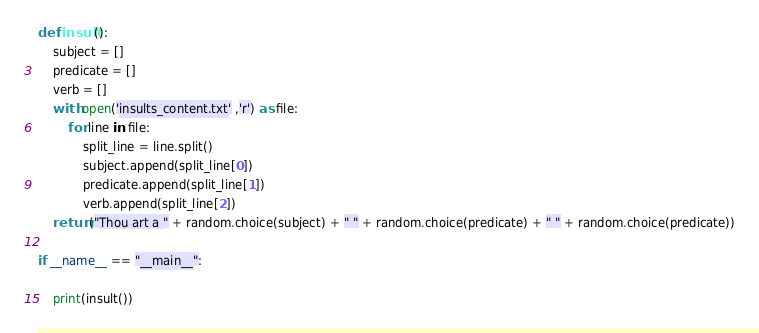Convert code to text. <code><loc_0><loc_0><loc_500><loc_500><_Python_>
def insult():
    subject = []
    predicate = []
    verb = []
    with open('insults_content.txt' ,'r') as file:
        for line in file:
            split_line = line.split()
            subject.append(split_line[0])
            predicate.append(split_line[1])
            verb.append(split_line[2])
    return("Thou art a " + random.choice(subject) + " " + random.choice(predicate) + " " + random.choice(predicate))

if __name__ == "__main__":

    print(insult())

</code> 